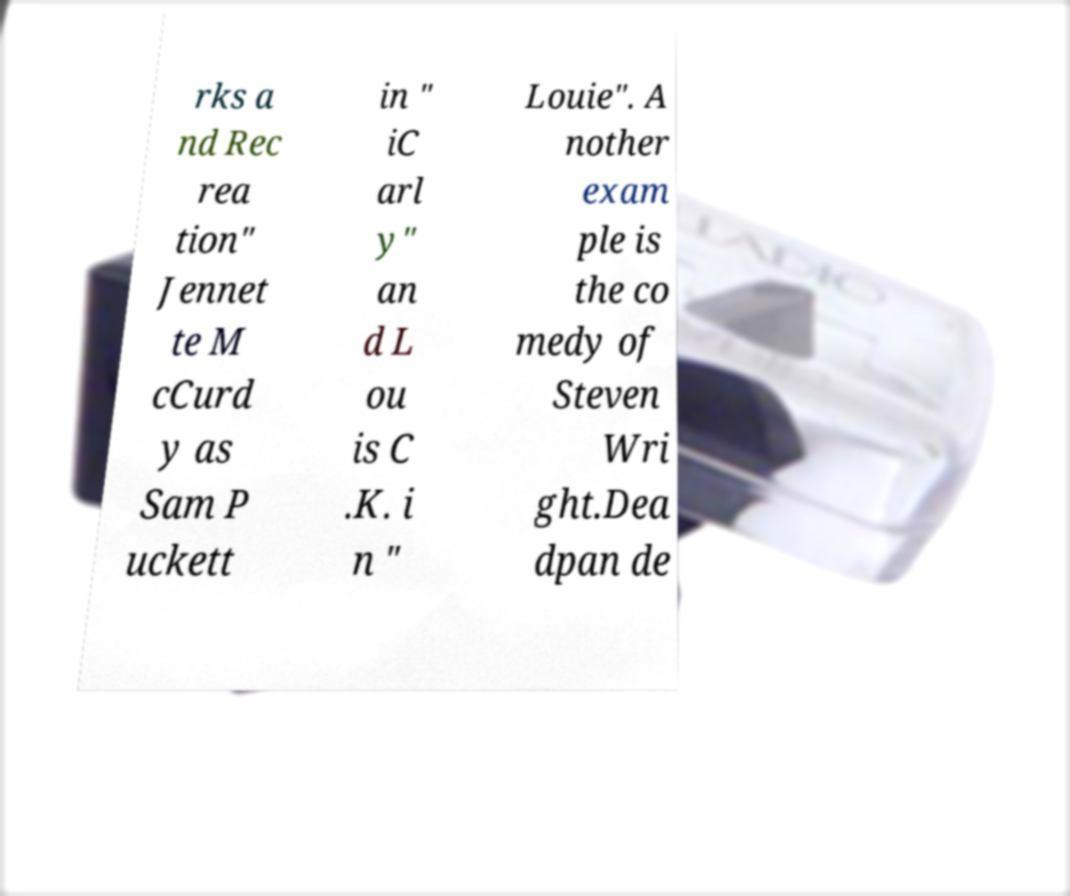Can you accurately transcribe the text from the provided image for me? rks a nd Rec rea tion" Jennet te M cCurd y as Sam P uckett in " iC arl y" an d L ou is C .K. i n " Louie". A nother exam ple is the co medy of Steven Wri ght.Dea dpan de 